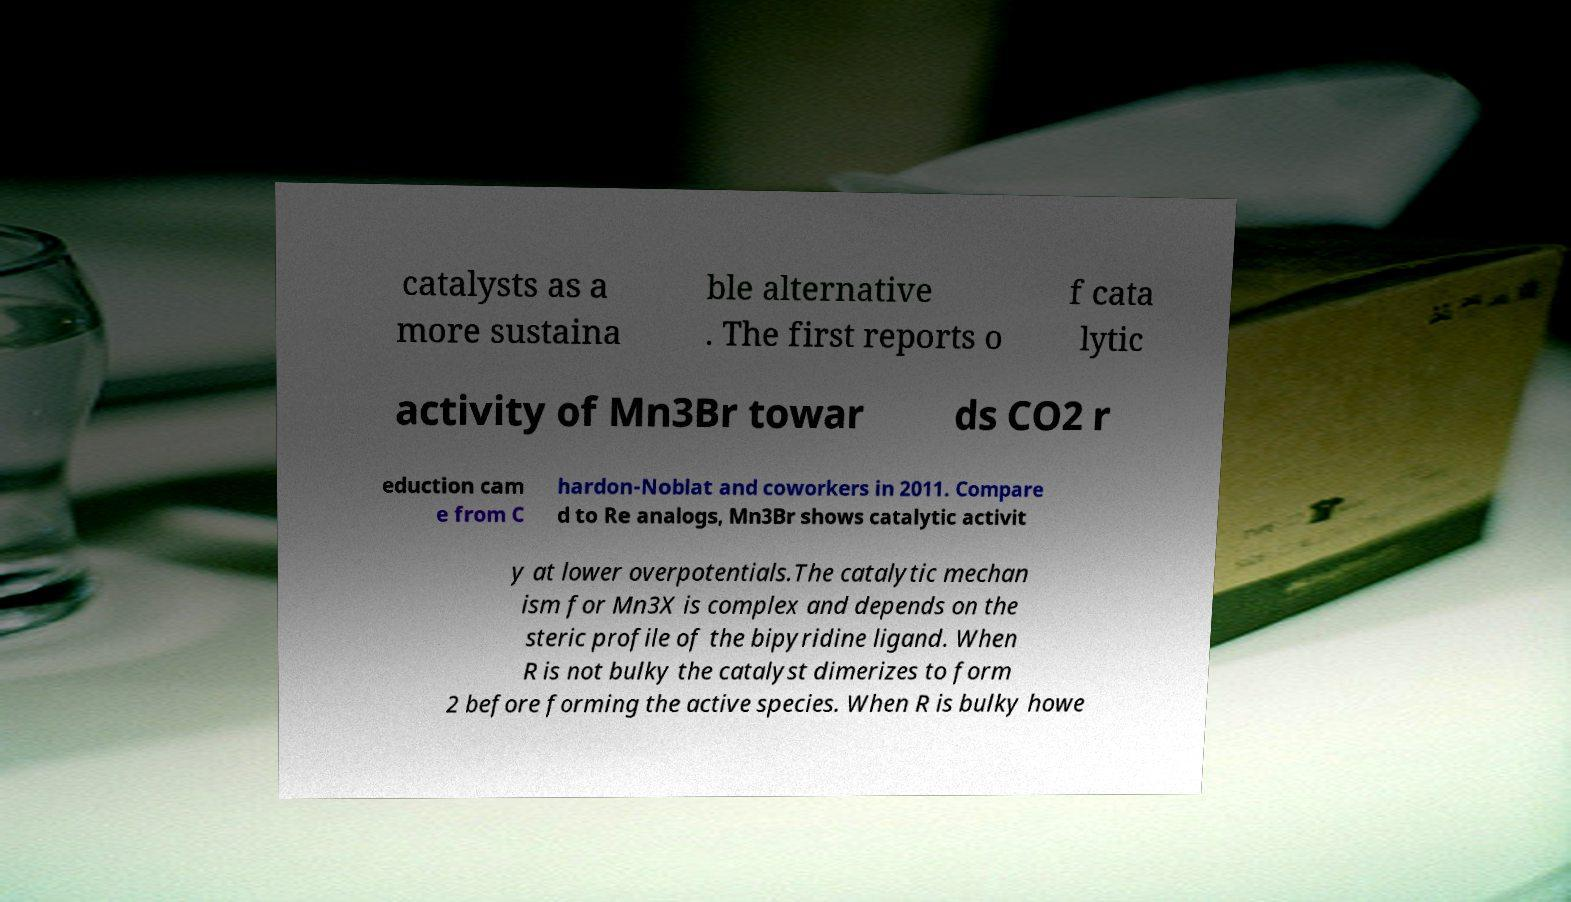Can you accurately transcribe the text from the provided image for me? catalysts as a more sustaina ble alternative . The first reports o f cata lytic activity of Mn3Br towar ds CO2 r eduction cam e from C hardon-Noblat and coworkers in 2011. Compare d to Re analogs, Mn3Br shows catalytic activit y at lower overpotentials.The catalytic mechan ism for Mn3X is complex and depends on the steric profile of the bipyridine ligand. When R is not bulky the catalyst dimerizes to form 2 before forming the active species. When R is bulky howe 